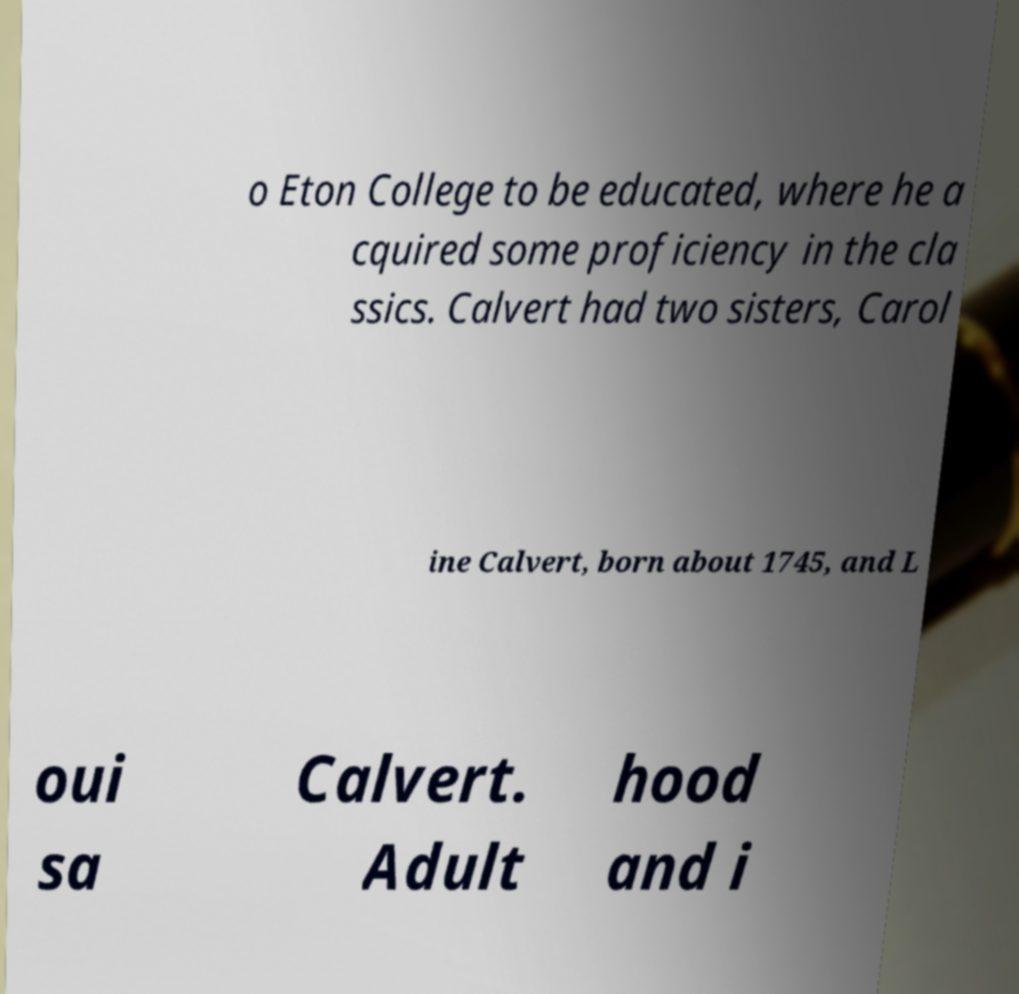I need the written content from this picture converted into text. Can you do that? o Eton College to be educated, where he a cquired some proficiency in the cla ssics. Calvert had two sisters, Carol ine Calvert, born about 1745, and L oui sa Calvert. Adult hood and i 